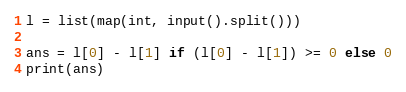<code> <loc_0><loc_0><loc_500><loc_500><_Python_>
l = list(map(int, input().split()))

ans = l[0] - l[1] if (l[0] - l[1]) >= 0 else 0
print(ans)</code> 